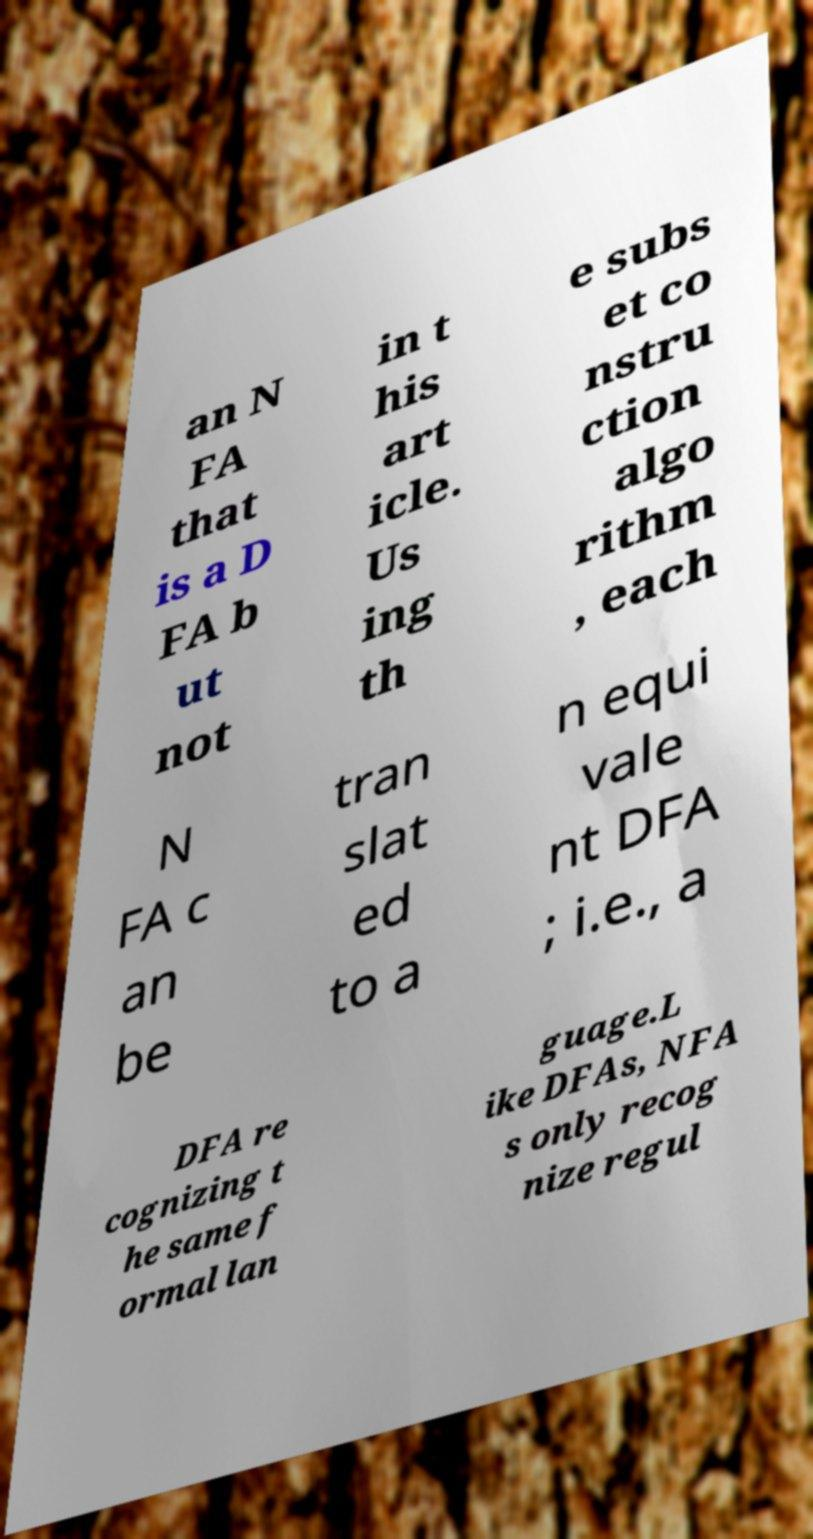For documentation purposes, I need the text within this image transcribed. Could you provide that? an N FA that is a D FA b ut not in t his art icle. Us ing th e subs et co nstru ction algo rithm , each N FA c an be tran slat ed to a n equi vale nt DFA ; i.e., a DFA re cognizing t he same f ormal lan guage.L ike DFAs, NFA s only recog nize regul 